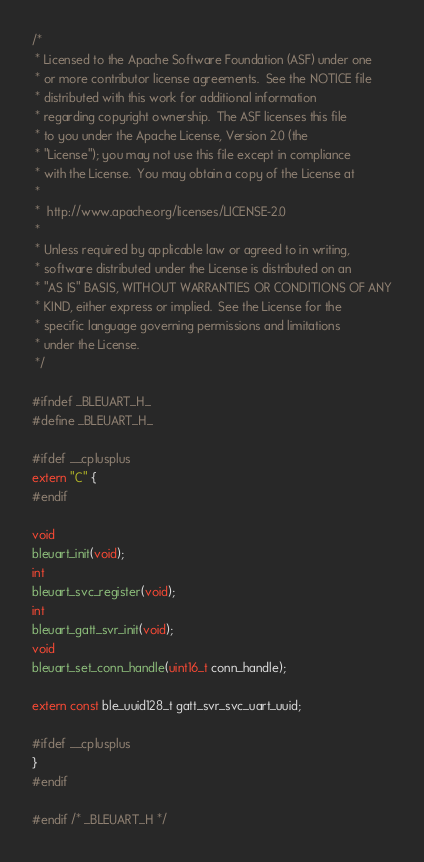Convert code to text. <code><loc_0><loc_0><loc_500><loc_500><_C_>/*
 * Licensed to the Apache Software Foundation (ASF) under one
 * or more contributor license agreements.  See the NOTICE file
 * distributed with this work for additional information
 * regarding copyright ownership.  The ASF licenses this file
 * to you under the Apache License, Version 2.0 (the
 * "License"); you may not use this file except in compliance
 * with the License.  You may obtain a copy of the License at
 *
 *  http://www.apache.org/licenses/LICENSE-2.0
 *
 * Unless required by applicable law or agreed to in writing,
 * software distributed under the License is distributed on an
 * "AS IS" BASIS, WITHOUT WARRANTIES OR CONDITIONS OF ANY
 * KIND, either express or implied.  See the License for the
 * specific language governing permissions and limitations
 * under the License.
 */

#ifndef _BLEUART_H_
#define _BLEUART_H_

#ifdef __cplusplus
extern "C" {
#endif

void
bleuart_init(void);
int
bleuart_svc_register(void);
int
bleuart_gatt_svr_init(void);
void
bleuart_set_conn_handle(uint16_t conn_handle);

extern const ble_uuid128_t gatt_svr_svc_uart_uuid;

#ifdef __cplusplus
}
#endif

#endif /* _BLEUART_H */
</code> 